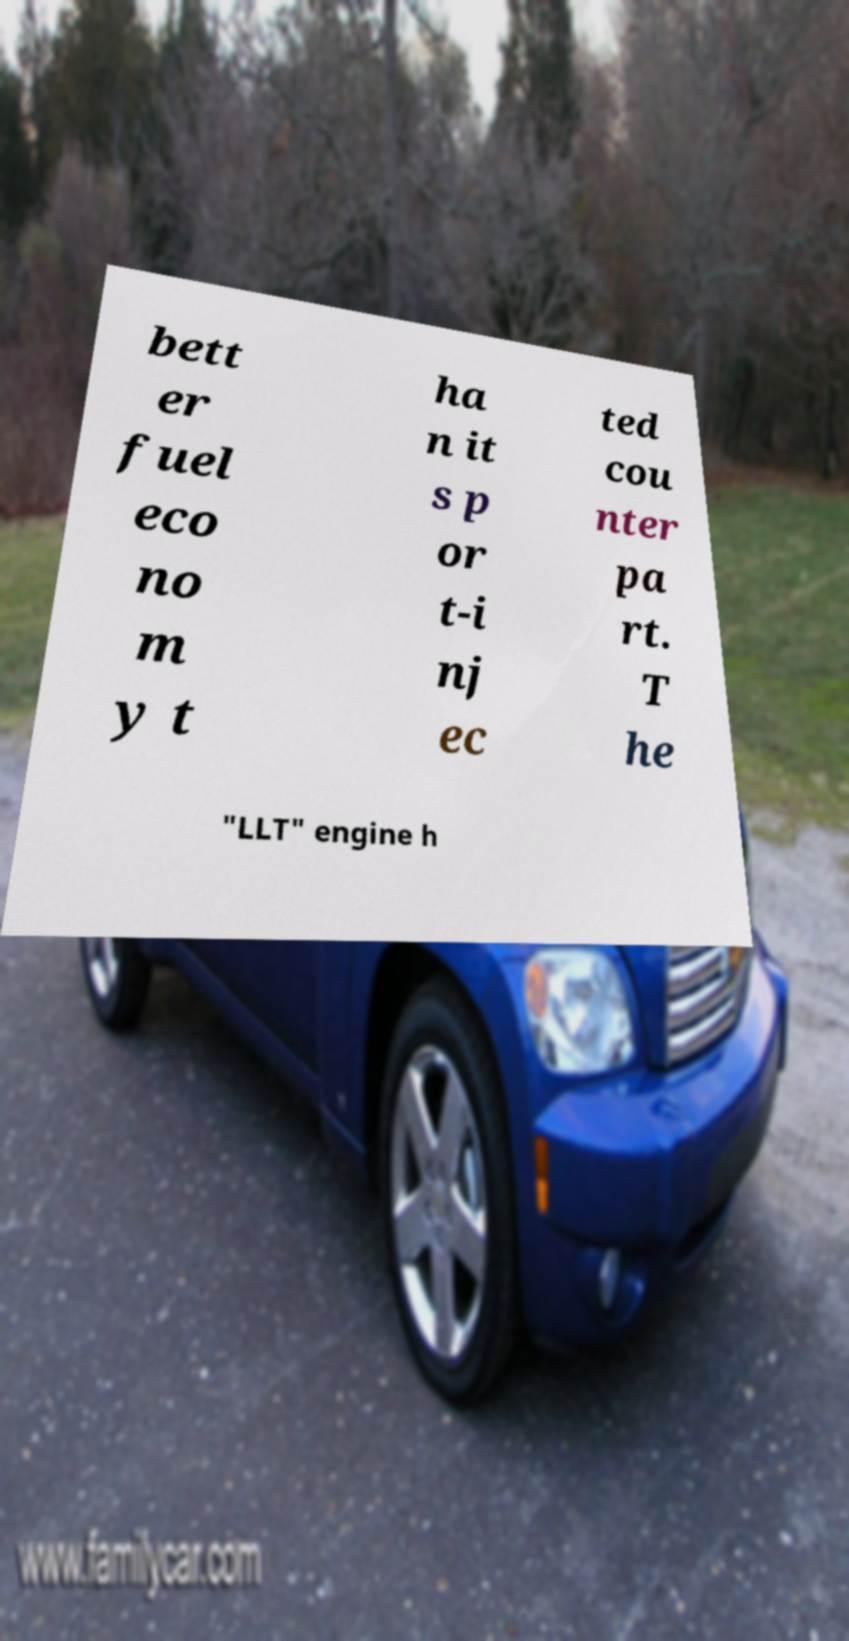Could you assist in decoding the text presented in this image and type it out clearly? bett er fuel eco no m y t ha n it s p or t-i nj ec ted cou nter pa rt. T he "LLT" engine h 